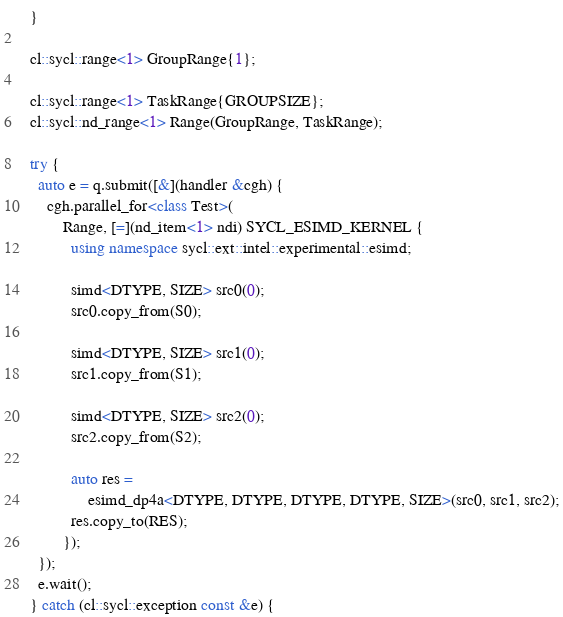Convert code to text. <code><loc_0><loc_0><loc_500><loc_500><_C++_>  }

  cl::sycl::range<1> GroupRange{1};

  cl::sycl::range<1> TaskRange{GROUPSIZE};
  cl::sycl::nd_range<1> Range(GroupRange, TaskRange);

  try {
    auto e = q.submit([&](handler &cgh) {
      cgh.parallel_for<class Test>(
          Range, [=](nd_item<1> ndi) SYCL_ESIMD_KERNEL {
            using namespace sycl::ext::intel::experimental::esimd;

            simd<DTYPE, SIZE> src0(0);
            src0.copy_from(S0);

            simd<DTYPE, SIZE> src1(0);
            src1.copy_from(S1);

            simd<DTYPE, SIZE> src2(0);
            src2.copy_from(S2);

            auto res =
                esimd_dp4a<DTYPE, DTYPE, DTYPE, DTYPE, SIZE>(src0, src1, src2);
            res.copy_to(RES);
          });
    });
    e.wait();
  } catch (cl::sycl::exception const &e) {</code> 